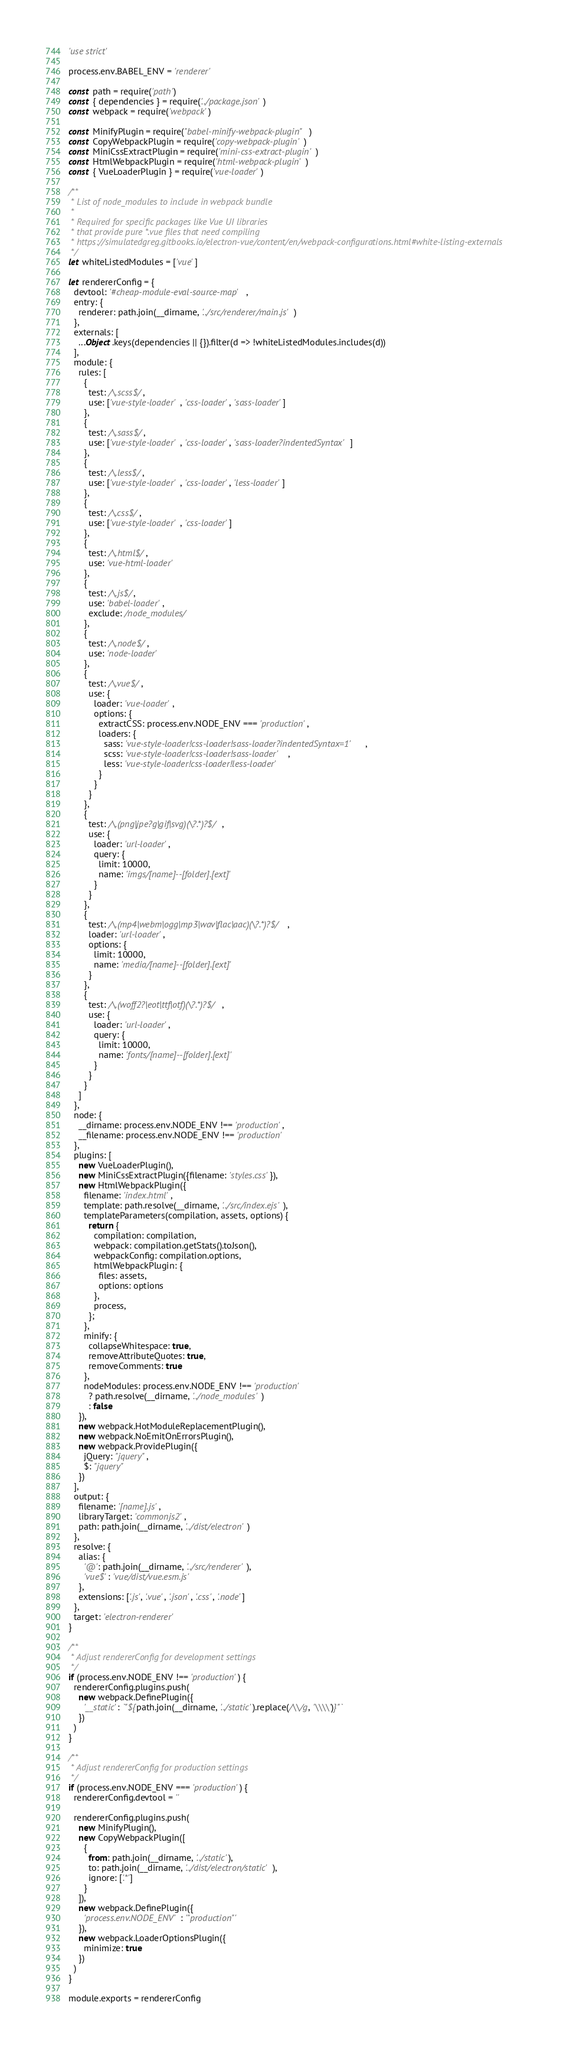Convert code to text. <code><loc_0><loc_0><loc_500><loc_500><_JavaScript_>'use strict'

process.env.BABEL_ENV = 'renderer'

const path = require('path')
const { dependencies } = require('../package.json')
const webpack = require('webpack')

const MinifyPlugin = require("babel-minify-webpack-plugin")
const CopyWebpackPlugin = require('copy-webpack-plugin')
const MiniCssExtractPlugin = require('mini-css-extract-plugin')
const HtmlWebpackPlugin = require('html-webpack-plugin')
const { VueLoaderPlugin } = require('vue-loader')

/**
 * List of node_modules to include in webpack bundle
 *
 * Required for specific packages like Vue UI libraries
 * that provide pure *.vue files that need compiling
 * https://simulatedgreg.gitbooks.io/electron-vue/content/en/webpack-configurations.html#white-listing-externals
 */
let whiteListedModules = ['vue']

let rendererConfig = {
  devtool: '#cheap-module-eval-source-map',
  entry: {
    renderer: path.join(__dirname, '../src/renderer/main.js')
  },
  externals: [
    ...Object.keys(dependencies || {}).filter(d => !whiteListedModules.includes(d))
  ],
  module: {
    rules: [
      {
        test: /\.scss$/,
        use: ['vue-style-loader', 'css-loader', 'sass-loader']
      },
      {
        test: /\.sass$/,
        use: ['vue-style-loader', 'css-loader', 'sass-loader?indentedSyntax']
      },
      {
        test: /\.less$/,
        use: ['vue-style-loader', 'css-loader', 'less-loader']
      },
      {
        test: /\.css$/,
        use: ['vue-style-loader', 'css-loader']
      },
      {
        test: /\.html$/,
        use: 'vue-html-loader'
      },
      {
        test: /\.js$/,
        use: 'babel-loader',
        exclude: /node_modules/
      },
      {
        test: /\.node$/,
        use: 'node-loader'
      },
      {
        test: /\.vue$/,
        use: {
          loader: 'vue-loader',
          options: {
            extractCSS: process.env.NODE_ENV === 'production',
            loaders: {
              sass: 'vue-style-loader!css-loader!sass-loader?indentedSyntax=1',
              scss: 'vue-style-loader!css-loader!sass-loader',
              less: 'vue-style-loader!css-loader!less-loader'
            }
          }
        }
      },
      {
        test: /\.(png|jpe?g|gif|svg)(\?.*)?$/,
        use: {
          loader: 'url-loader',
          query: {
            limit: 10000,
            name: 'imgs/[name]--[folder].[ext]'
          }
        }
      },
      {
        test: /\.(mp4|webm|ogg|mp3|wav|flac|aac)(\?.*)?$/,
        loader: 'url-loader',
        options: {
          limit: 10000,
          name: 'media/[name]--[folder].[ext]'
        }
      },
      {
        test: /\.(woff2?|eot|ttf|otf)(\?.*)?$/,
        use: {
          loader: 'url-loader',
          query: {
            limit: 10000,
            name: 'fonts/[name]--[folder].[ext]'
          }
        }
      }
    ]
  },
  node: {
    __dirname: process.env.NODE_ENV !== 'production',
    __filename: process.env.NODE_ENV !== 'production'
  },
  plugins: [
    new VueLoaderPlugin(),
    new MiniCssExtractPlugin({filename: 'styles.css'}),
    new HtmlWebpackPlugin({
      filename: 'index.html',
      template: path.resolve(__dirname, '../src/index.ejs'),
      templateParameters(compilation, assets, options) {
        return {
          compilation: compilation,
          webpack: compilation.getStats().toJson(),
          webpackConfig: compilation.options,
          htmlWebpackPlugin: {
            files: assets,
            options: options
          },
          process,
        };
      },
      minify: {
        collapseWhitespace: true,
        removeAttributeQuotes: true,
        removeComments: true
      },
      nodeModules: process.env.NODE_ENV !== 'production'
        ? path.resolve(__dirname, '../node_modules')
        : false
    }),
    new webpack.HotModuleReplacementPlugin(),
    new webpack.NoEmitOnErrorsPlugin(),
    new webpack.ProvidePlugin({
      jQuery: "jquery",
      $: "jquery"
    })
  ],
  output: {
    filename: '[name].js',
    libraryTarget: 'commonjs2',
    path: path.join(__dirname, '../dist/electron')
  },
  resolve: {
    alias: {
      '@': path.join(__dirname, '../src/renderer'),
      'vue$': 'vue/dist/vue.esm.js'
    },
    extensions: ['.js', '.vue', '.json', '.css', '.node']
  },
  target: 'electron-renderer'
}

/**
 * Adjust rendererConfig for development settings
 */
if (process.env.NODE_ENV !== 'production') {
  rendererConfig.plugins.push(
    new webpack.DefinePlugin({
      '__static': `"${path.join(__dirname, '../static').replace(/\\/g, '\\\\')}"`
    })
  )
}

/**
 * Adjust rendererConfig for production settings
 */
if (process.env.NODE_ENV === 'production') {
  rendererConfig.devtool = ''

  rendererConfig.plugins.push(
    new MinifyPlugin(),
    new CopyWebpackPlugin([
      {
        from: path.join(__dirname, '../static'),
        to: path.join(__dirname, '../dist/electron/static'),
        ignore: ['.*']
      }
    ]),
    new webpack.DefinePlugin({
      'process.env.NODE_ENV': '"production"'
    }),
    new webpack.LoaderOptionsPlugin({
      minimize: true
    })
  )
}

module.exports = rendererConfig
</code> 